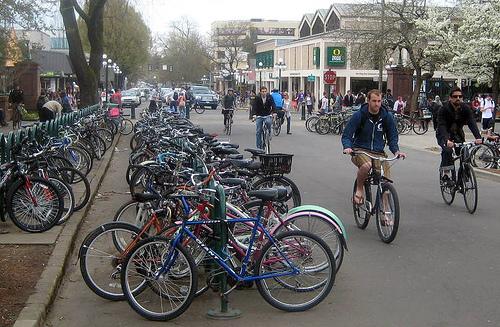How many have riders?
Keep it brief. 5. Does the second cyclist look like they are training for competition?
Write a very short answer. No. What are the people riding?
Keep it brief. Bikes. What is the weather in this scene?
Be succinct. Cloudy. How many 'bike baskets' are there in the photo?
Give a very brief answer. 1. Does the bike look brand new?
Quick response, please. No. Is the bald man facing the camera?
Concise answer only. No. How many bikes are in the photo?
Write a very short answer. Many. Are the bikes in a parking lot?
Answer briefly. Yes. Is this urban or suburban?
Answer briefly. Urban. Is there more than one bike in the photo?
Be succinct. Yes. 